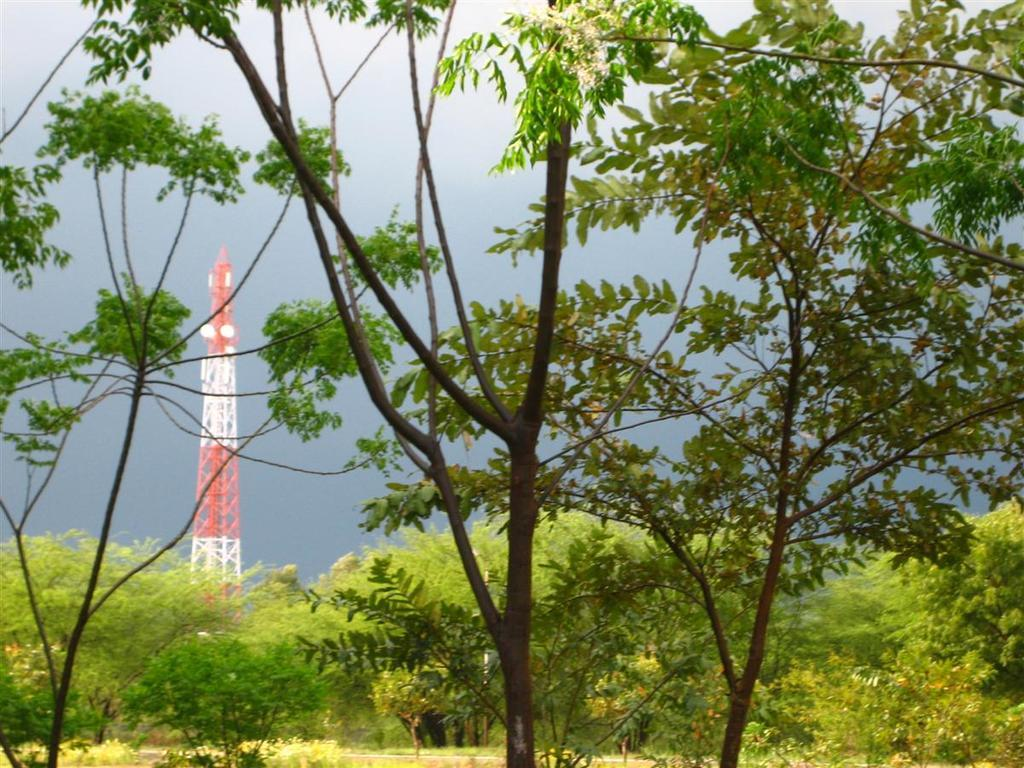What type of vegetation can be seen in the image? There are trees in the image. Where is the tower located in the image? The tower is on the left side of the image. What is visible in the background of the image? The sky is visible in the background of the image. What type of corn can be seen growing near the tower in the image? There is no corn present in the image; it only features trees and a tower. What drug is being used by the people in the image? There are no people or drugs present in the image. 